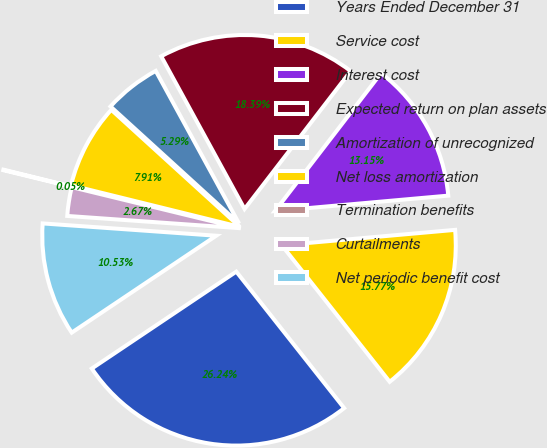Convert chart to OTSL. <chart><loc_0><loc_0><loc_500><loc_500><pie_chart><fcel>Years Ended December 31<fcel>Service cost<fcel>Interest cost<fcel>Expected return on plan assets<fcel>Amortization of unrecognized<fcel>Net loss amortization<fcel>Termination benefits<fcel>Curtailments<fcel>Net periodic benefit cost<nl><fcel>26.24%<fcel>15.77%<fcel>13.15%<fcel>18.39%<fcel>5.29%<fcel>7.91%<fcel>0.05%<fcel>2.67%<fcel>10.53%<nl></chart> 